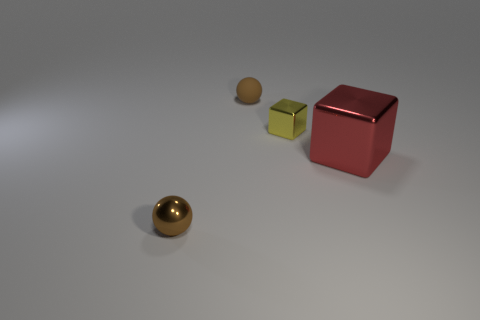What size is the thing that is the same color as the small matte sphere?
Your answer should be compact. Small. Are there any gray cylinders that have the same material as the red block?
Provide a succinct answer. No. What is the color of the large thing?
Your answer should be very brief. Red. What is the size of the brown ball behind the small brown ball that is in front of the brown thing that is behind the big red object?
Offer a very short reply. Small. What number of other objects are there of the same shape as the yellow object?
Offer a terse response. 1. The shiny thing that is both behind the small metal ball and to the left of the red thing is what color?
Offer a very short reply. Yellow. Is there anything else that has the same size as the yellow metal block?
Provide a short and direct response. Yes. Do the tiny ball that is in front of the yellow shiny thing and the small matte ball have the same color?
Offer a terse response. Yes. How many spheres are either red objects or yellow things?
Keep it short and to the point. 0. What shape is the tiny thing left of the brown matte object?
Make the answer very short. Sphere. 